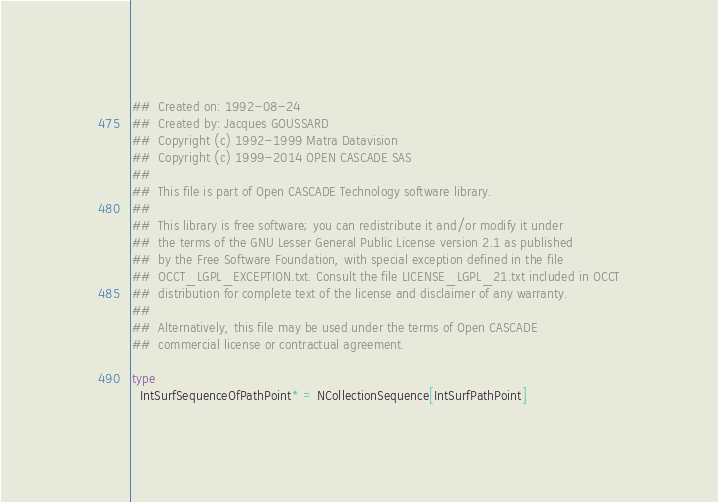<code> <loc_0><loc_0><loc_500><loc_500><_Nim_>##  Created on: 1992-08-24
##  Created by: Jacques GOUSSARD
##  Copyright (c) 1992-1999 Matra Datavision
##  Copyright (c) 1999-2014 OPEN CASCADE SAS
##
##  This file is part of Open CASCADE Technology software library.
##
##  This library is free software; you can redistribute it and/or modify it under
##  the terms of the GNU Lesser General Public License version 2.1 as published
##  by the Free Software Foundation, with special exception defined in the file
##  OCCT_LGPL_EXCEPTION.txt. Consult the file LICENSE_LGPL_21.txt included in OCCT
##  distribution for complete text of the license and disclaimer of any warranty.
##
##  Alternatively, this file may be used under the terms of Open CASCADE
##  commercial license or contractual agreement.

type
  IntSurfSequenceOfPathPoint* = NCollectionSequence[IntSurfPathPoint]


























</code> 